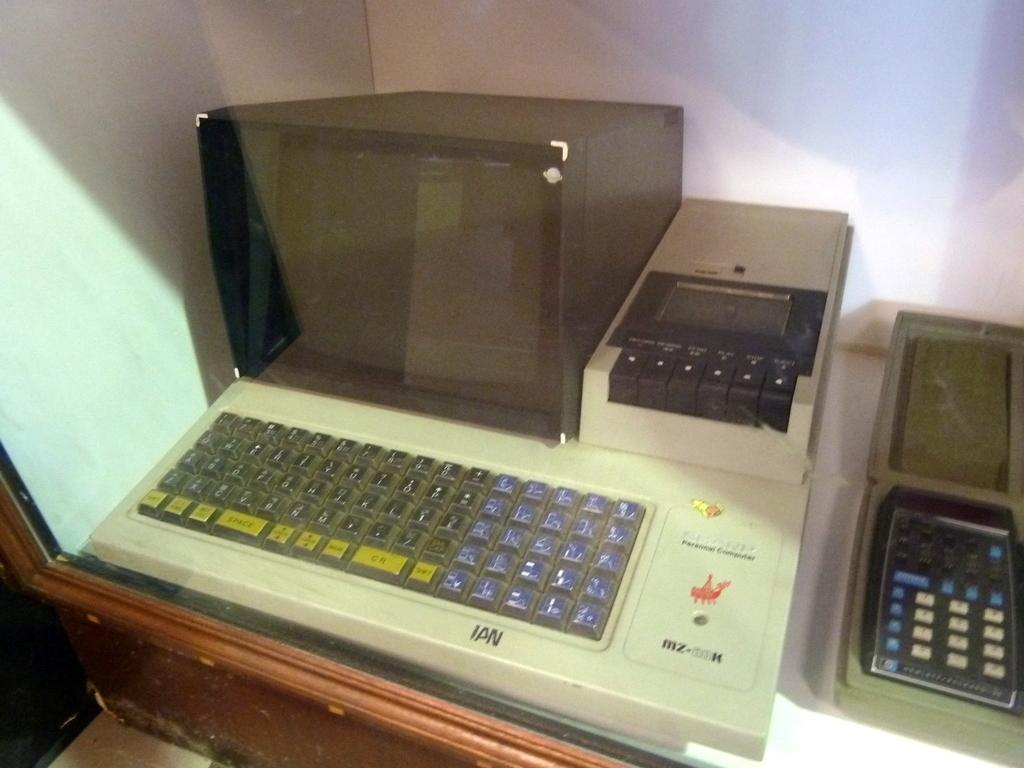Provide a one-sentence caption for the provided image. An old fashioned Sharp Personal computer sits on a desk. 